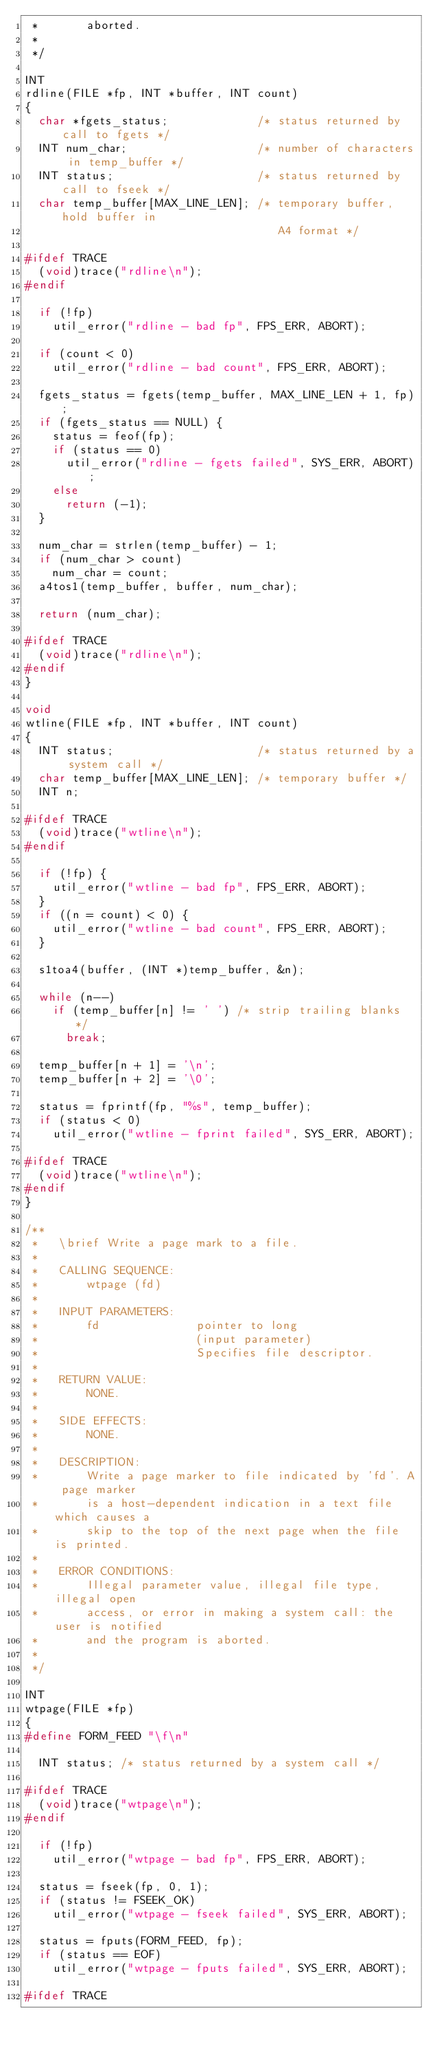Convert code to text. <code><loc_0><loc_0><loc_500><loc_500><_C_> *       aborted.
 *
 */

INT
rdline(FILE *fp, INT *buffer, INT count)
{
  char *fgets_status;             /* status returned by call to fgets */
  INT num_char;                   /* number of characters in temp_buffer */
  INT status;                     /* status returned by call to fseek */
  char temp_buffer[MAX_LINE_LEN]; /* temporary buffer, hold buffer in
                                     A4 format */

#ifdef TRACE
  (void)trace("rdline\n");
#endif

  if (!fp)
    util_error("rdline - bad fp", FPS_ERR, ABORT);

  if (count < 0)
    util_error("rdline - bad count", FPS_ERR, ABORT);

  fgets_status = fgets(temp_buffer, MAX_LINE_LEN + 1, fp);
  if (fgets_status == NULL) {
    status = feof(fp);
    if (status == 0)
      util_error("rdline - fgets failed", SYS_ERR, ABORT);
    else
      return (-1);
  }

  num_char = strlen(temp_buffer) - 1;
  if (num_char > count)
    num_char = count;
  a4tos1(temp_buffer, buffer, num_char);

  return (num_char);

#ifdef TRACE
  (void)trace("rdline\n");
#endif
}

void
wtline(FILE *fp, INT *buffer, INT count)
{
  INT status;                     /* status returned by a system call */
  char temp_buffer[MAX_LINE_LEN]; /* temporary buffer */
  INT n;

#ifdef TRACE
  (void)trace("wtline\n");
#endif

  if (!fp) {
    util_error("wtline - bad fp", FPS_ERR, ABORT);
  }
  if ((n = count) < 0) {
    util_error("wtline - bad count", FPS_ERR, ABORT);
  }

  s1toa4(buffer, (INT *)temp_buffer, &n);

  while (n--)
    if (temp_buffer[n] != ' ') /* strip trailing blanks */
      break;

  temp_buffer[n + 1] = '\n';
  temp_buffer[n + 2] = '\0';

  status = fprintf(fp, "%s", temp_buffer);
  if (status < 0)
    util_error("wtline - fprint failed", SYS_ERR, ABORT);

#ifdef TRACE
  (void)trace("wtline\n");
#endif
}

/**
 *   \brief Write a page mark to a file.
 *
 *   CALLING SEQUENCE:
 *       wtpage (fd)
 *
 *   INPUT PARAMETERS:
 *       fd              pointer to long
 *                       (input parameter)
 *                       Specifies file descriptor.
 *
 *   RETURN VALUE:
 *       NONE.
 *
 *   SIDE EFFECTS:
 *       NONE.
 *
 *   DESCRIPTION:
 *       Write a page marker to file indicated by 'fd'. A page marker
 *       is a host-dependent indication in a text file which causes a
 *       skip to the top of the next page when the file is printed.
 *
 *   ERROR CONDITIONS:
 *       Illegal parameter value, illegal file type, illegal open
 *       access, or error in making a system call: the user is notified
 *       and the program is aborted.
 *
 */

INT
wtpage(FILE *fp)
{
#define FORM_FEED "\f\n"

  INT status; /* status returned by a system call */

#ifdef TRACE
  (void)trace("wtpage\n");
#endif

  if (!fp)
    util_error("wtpage - bad fp", FPS_ERR, ABORT);

  status = fseek(fp, 0, 1);
  if (status != FSEEK_OK)
    util_error("wtpage - fseek failed", SYS_ERR, ABORT);

  status = fputs(FORM_FEED, fp);
  if (status == EOF)
    util_error("wtpage - fputs failed", SYS_ERR, ABORT);

#ifdef TRACE</code> 